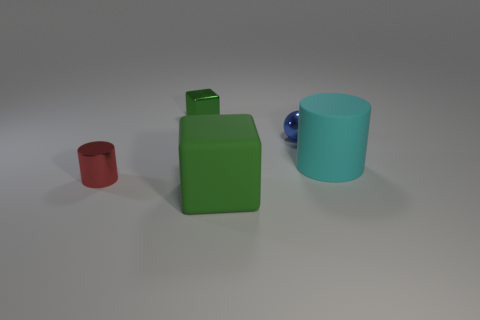Add 4 red matte cubes. How many objects exist? 9 Subtract all cylinders. How many objects are left? 3 Subtract 1 cylinders. How many cylinders are left? 1 Subtract all red blocks. Subtract all yellow cylinders. How many blocks are left? 2 Subtract all large purple shiny blocks. Subtract all big matte objects. How many objects are left? 3 Add 2 green rubber things. How many green rubber things are left? 3 Add 1 matte things. How many matte things exist? 3 Subtract 1 red cylinders. How many objects are left? 4 